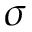Convert formula to latex. <formula><loc_0><loc_0><loc_500><loc_500>\sigma</formula> 